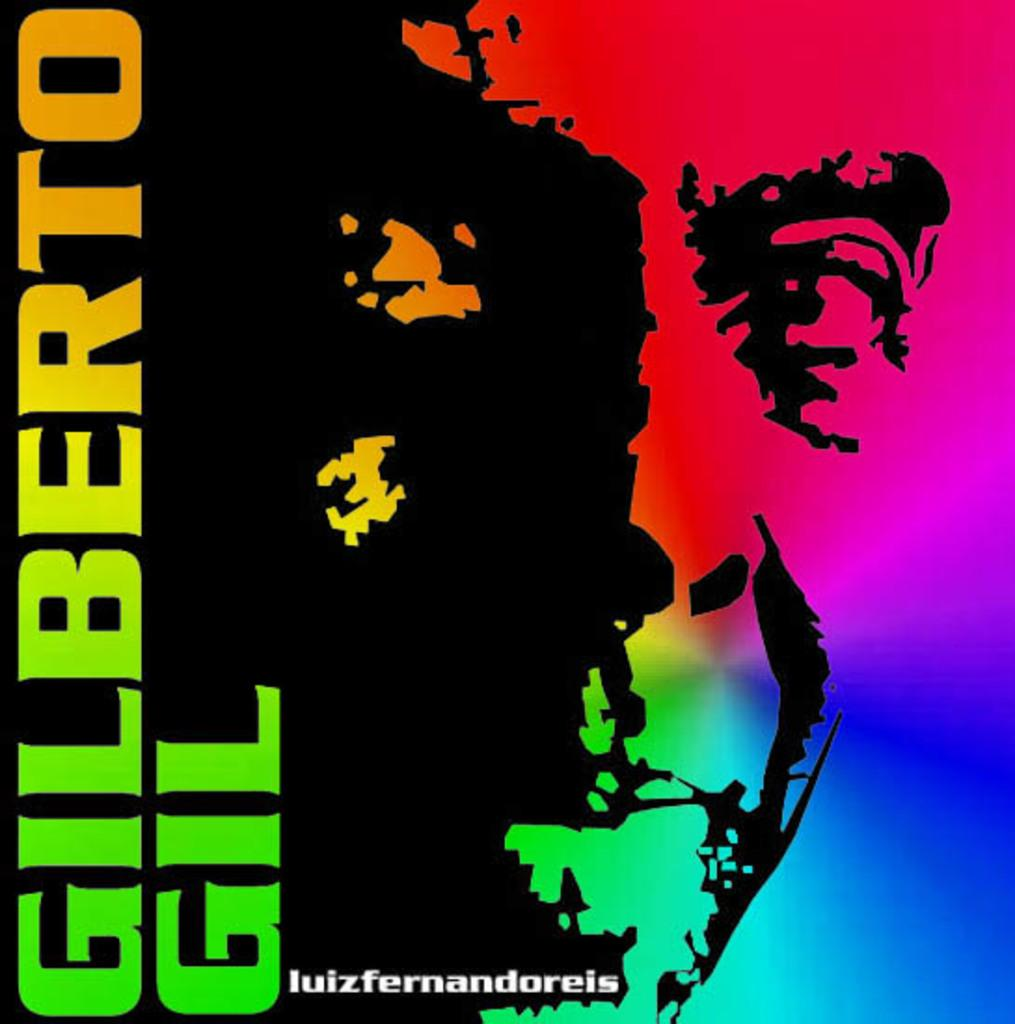What can be found on the left side of the image? There is text on the left side of the image. What type of visual is the image? The image appears to be a poster. What is depicted in the image besides the text? There is a painting of a person's face in the image. Can you see any paint being used in the image? There is no paint visible in the image, as it features a poster with text and a painting of a person's face. Is there a quiver present in the image? There is no quiver present in the image. 